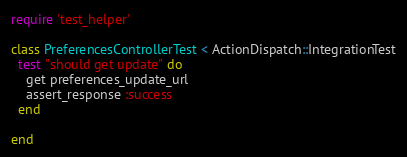Convert code to text. <code><loc_0><loc_0><loc_500><loc_500><_Ruby_>require 'test_helper'

class PreferencesControllerTest < ActionDispatch::IntegrationTest
  test "should get update" do
    get preferences_update_url
    assert_response :success
  end

end
</code> 